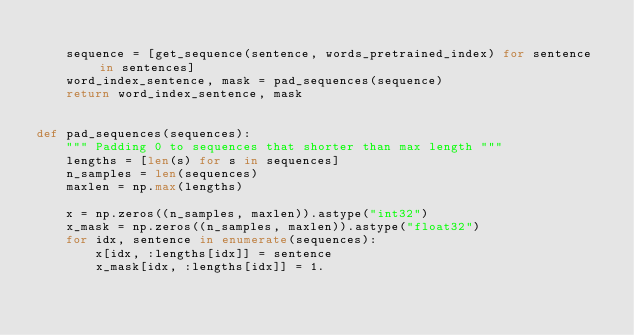<code> <loc_0><loc_0><loc_500><loc_500><_Python_>
    sequence = [get_sequence(sentence, words_pretrained_index) for sentence in sentences]
    word_index_sentence, mask = pad_sequences(sequence)
    return word_index_sentence, mask


def pad_sequences(sequences):
    """ Padding 0 to sequences that shorter than max length """
    lengths = [len(s) for s in sequences]
    n_samples = len(sequences)
    maxlen = np.max(lengths)

    x = np.zeros((n_samples, maxlen)).astype("int32")
    x_mask = np.zeros((n_samples, maxlen)).astype("float32")
    for idx, sentence in enumerate(sequences):
        x[idx, :lengths[idx]] = sentence
        x_mask[idx, :lengths[idx]] = 1.</code> 